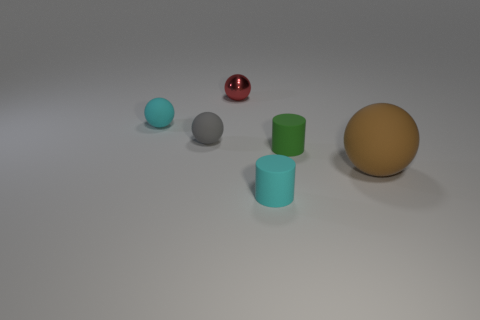Are there any other things that are the same size as the brown matte sphere?
Offer a terse response. No. Do the shiny ball and the green matte cylinder that is right of the red ball have the same size?
Offer a terse response. Yes. There is a matte sphere that is right of the sphere behind the cyan object behind the large rubber object; what size is it?
Provide a short and direct response. Large. How many things are either tiny matte objects left of the tiny green cylinder or big brown rubber things?
Make the answer very short. 4. How many small spheres are on the left side of the large brown matte sphere in front of the tiny green rubber cylinder?
Provide a succinct answer. 3. Is the number of tiny cyan matte objects that are in front of the large brown rubber ball greater than the number of big yellow spheres?
Your answer should be compact. Yes. What is the size of the sphere that is both to the right of the tiny gray sphere and in front of the tiny cyan matte sphere?
Keep it short and to the point. Large. What is the shape of the thing that is in front of the small green cylinder and left of the tiny green matte thing?
Ensure brevity in your answer.  Cylinder. There is a small cyan thing on the right side of the cyan object that is left of the small metallic object; are there any cylinders that are on the right side of it?
Give a very brief answer. Yes. How many objects are tiny objects right of the small gray matte object or small cylinders to the left of the tiny green matte thing?
Offer a terse response. 3. 